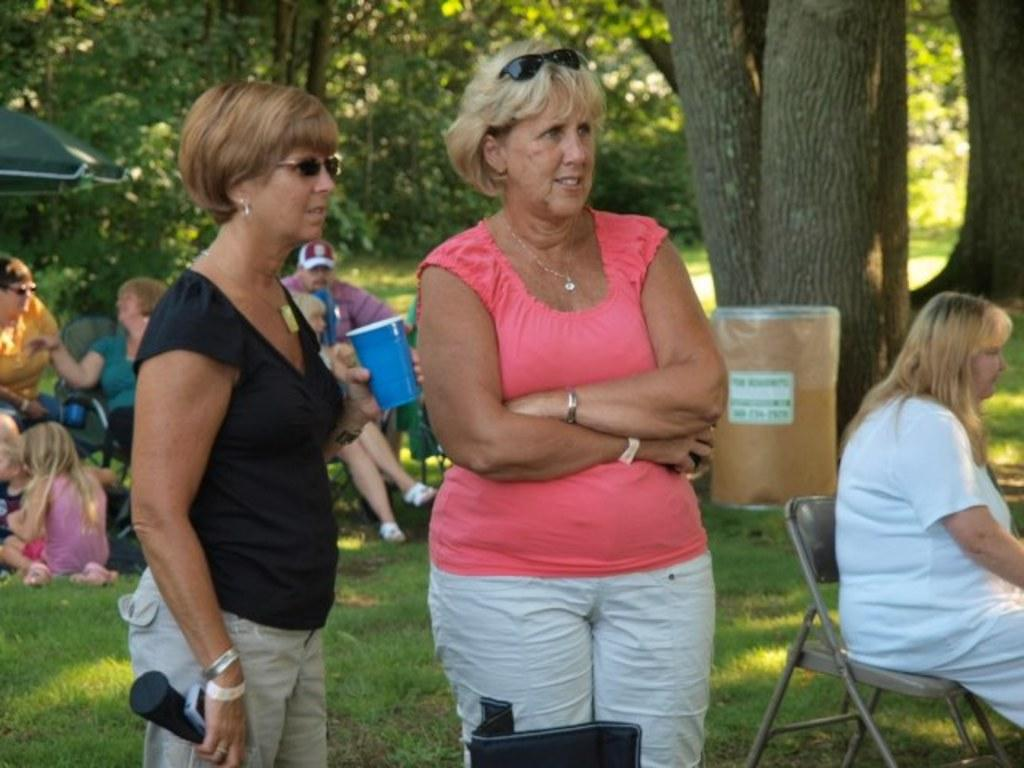What is the setting of the image? The setting of the image is a garden. What are the women in the garden doing? Some women are standing, while others are sitting. What can be seen in the background of the image? There is a dustbin and trees in the background. What type of books are the women reading in the image? There are no books present in the image; the women are in a garden, with some standing and others sitting. 